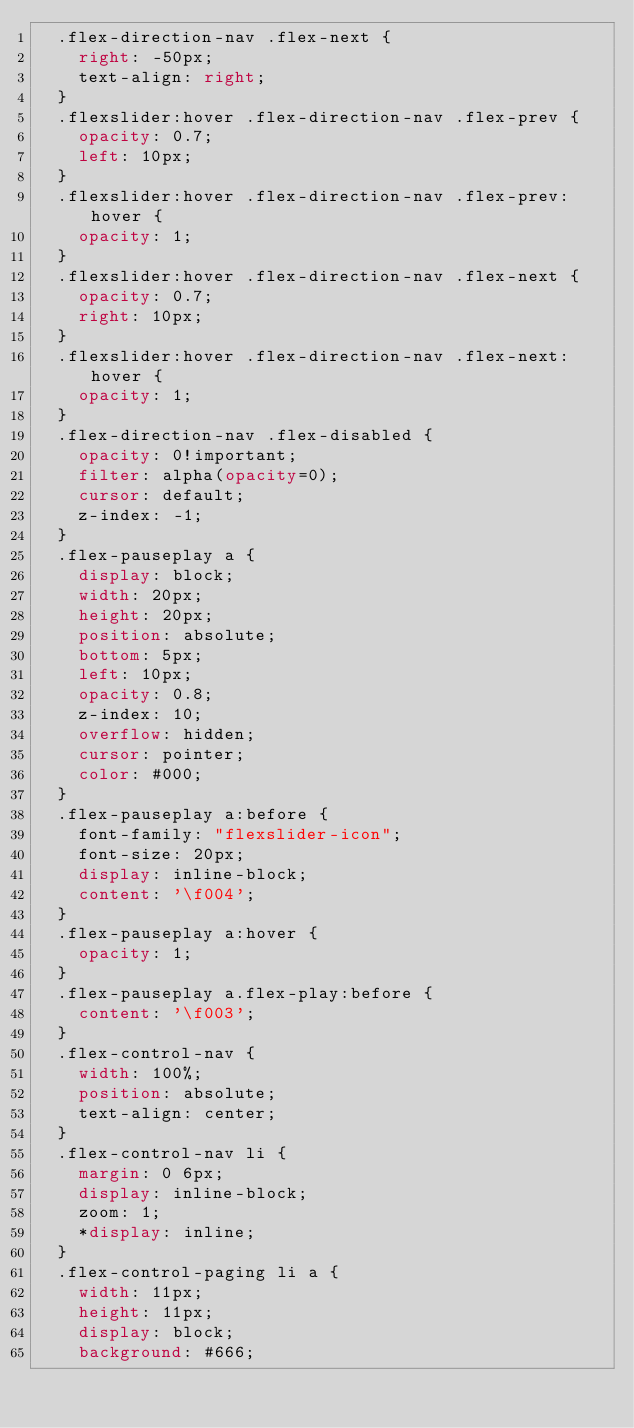Convert code to text. <code><loc_0><loc_0><loc_500><loc_500><_CSS_>  .flex-direction-nav .flex-next {
    right: -50px;
    text-align: right;
  }
  .flexslider:hover .flex-direction-nav .flex-prev {
    opacity: 0.7;
    left: 10px;
  }
  .flexslider:hover .flex-direction-nav .flex-prev:hover {
    opacity: 1;
  }
  .flexslider:hover .flex-direction-nav .flex-next {
    opacity: 0.7;
    right: 10px;
  }
  .flexslider:hover .flex-direction-nav .flex-next:hover {
    opacity: 1;
  }
  .flex-direction-nav .flex-disabled {
    opacity: 0!important;
    filter: alpha(opacity=0);
    cursor: default;
    z-index: -1;
  }
  .flex-pauseplay a {
    display: block;
    width: 20px;
    height: 20px;
    position: absolute;
    bottom: 5px;
    left: 10px;
    opacity: 0.8;
    z-index: 10;
    overflow: hidden;
    cursor: pointer;
    color: #000;
  }
  .flex-pauseplay a:before {
    font-family: "flexslider-icon";
    font-size: 20px;
    display: inline-block;
    content: '\f004';
  }
  .flex-pauseplay a:hover {
    opacity: 1;
  }
  .flex-pauseplay a.flex-play:before {
    content: '\f003';
  }
  .flex-control-nav {
    width: 100%;
    position: absolute;
    text-align: center;
  }
  .flex-control-nav li {
    margin: 0 6px;
    display: inline-block;
    zoom: 1;
    *display: inline;
  }
  .flex-control-paging li a {
    width: 11px;
    height: 11px;
    display: block;
    background: #666;</code> 